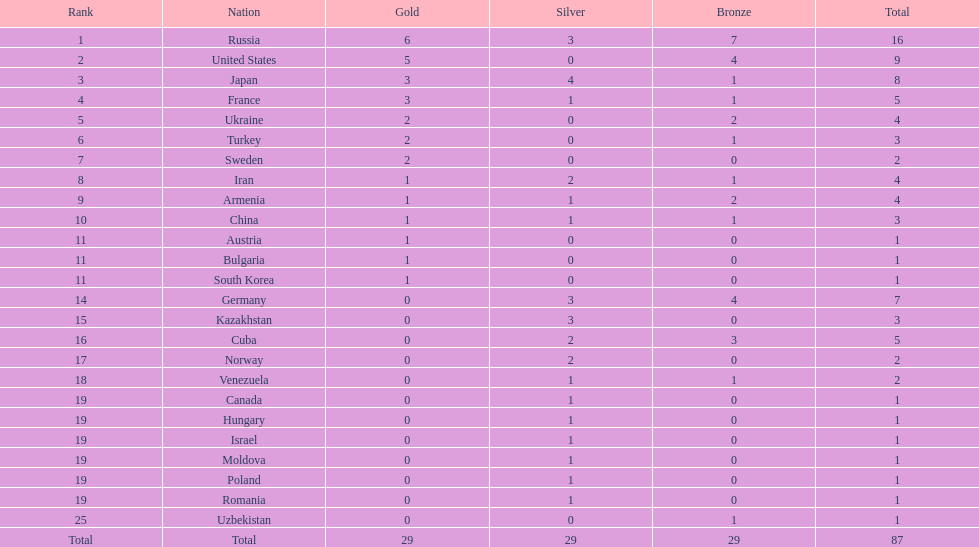What is the number of gold medals won by both japan and france? 3. 